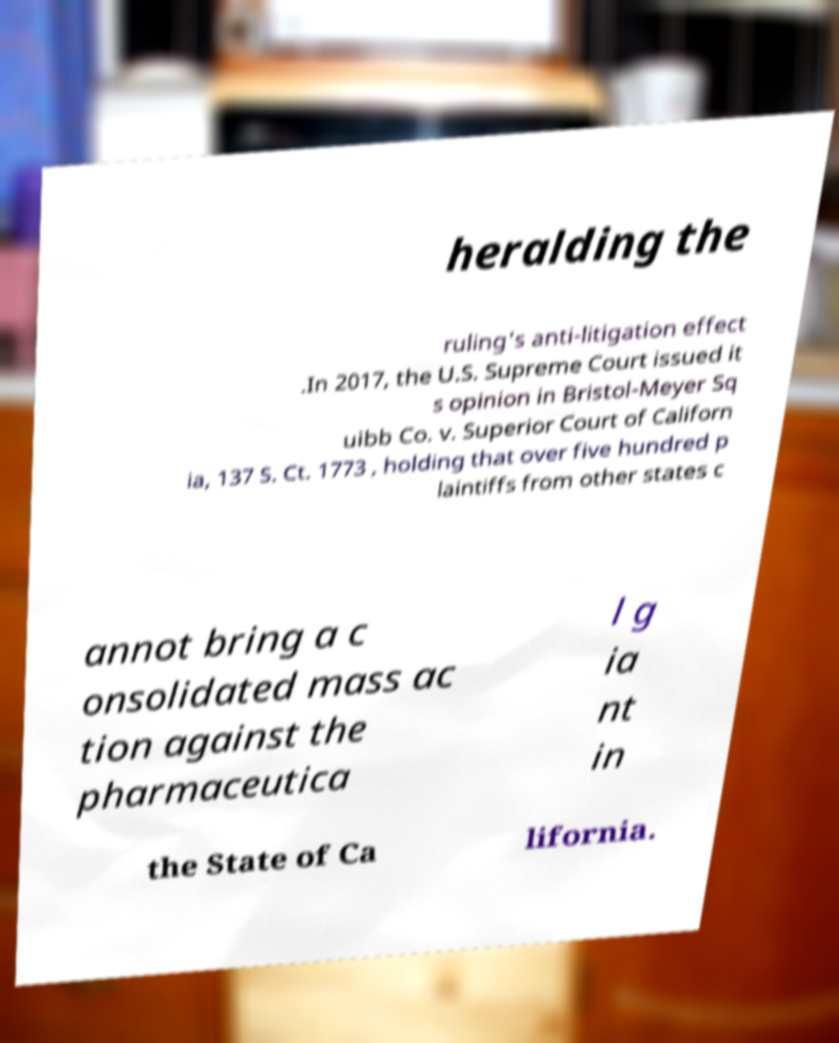Please read and relay the text visible in this image. What does it say? heralding the ruling's anti-litigation effect .In 2017, the U.S. Supreme Court issued it s opinion in Bristol-Meyer Sq uibb Co. v. Superior Court of Californ ia, 137 S. Ct. 1773 , holding that over five hundred p laintiffs from other states c annot bring a c onsolidated mass ac tion against the pharmaceutica l g ia nt in the State of Ca lifornia. 